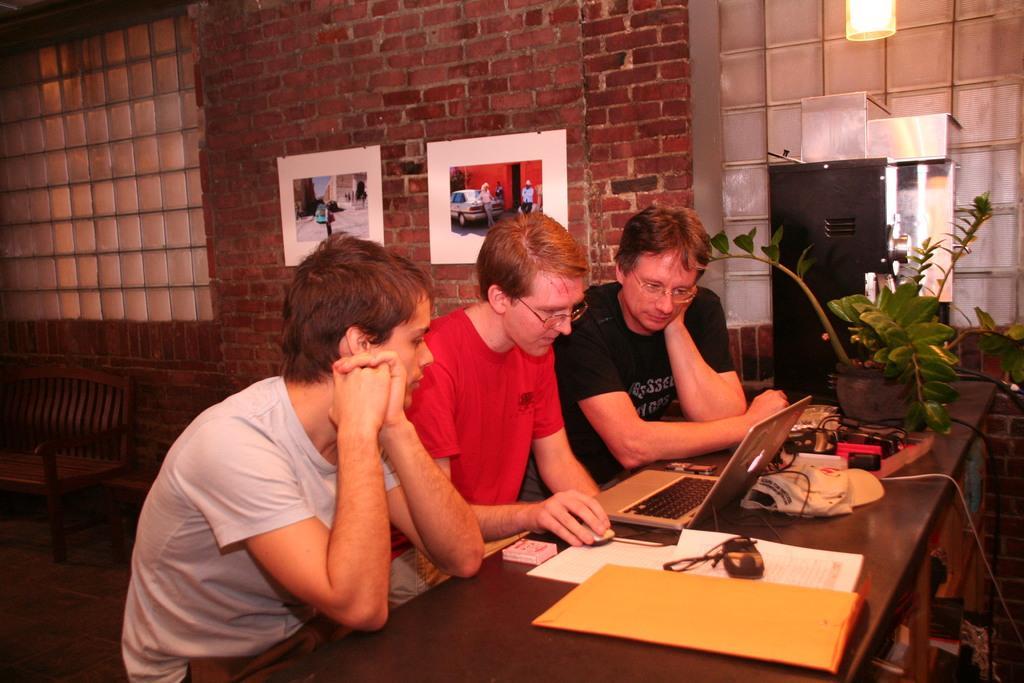In one or two sentences, can you explain what this image depicts? In this picture we can see three persons are sitting on the chairs. This is table. On the table there are papers, laptop, and cables. This is plant. On the background there is a wall and these are the frames. And this is light. 